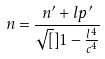Convert formula to latex. <formula><loc_0><loc_0><loc_500><loc_500>n = \frac { n ^ { \prime } + l p ^ { \prime } } { \sqrt { [ } ] { 1 - \frac { l ^ { 4 } } { c ^ { 4 } } } }</formula> 